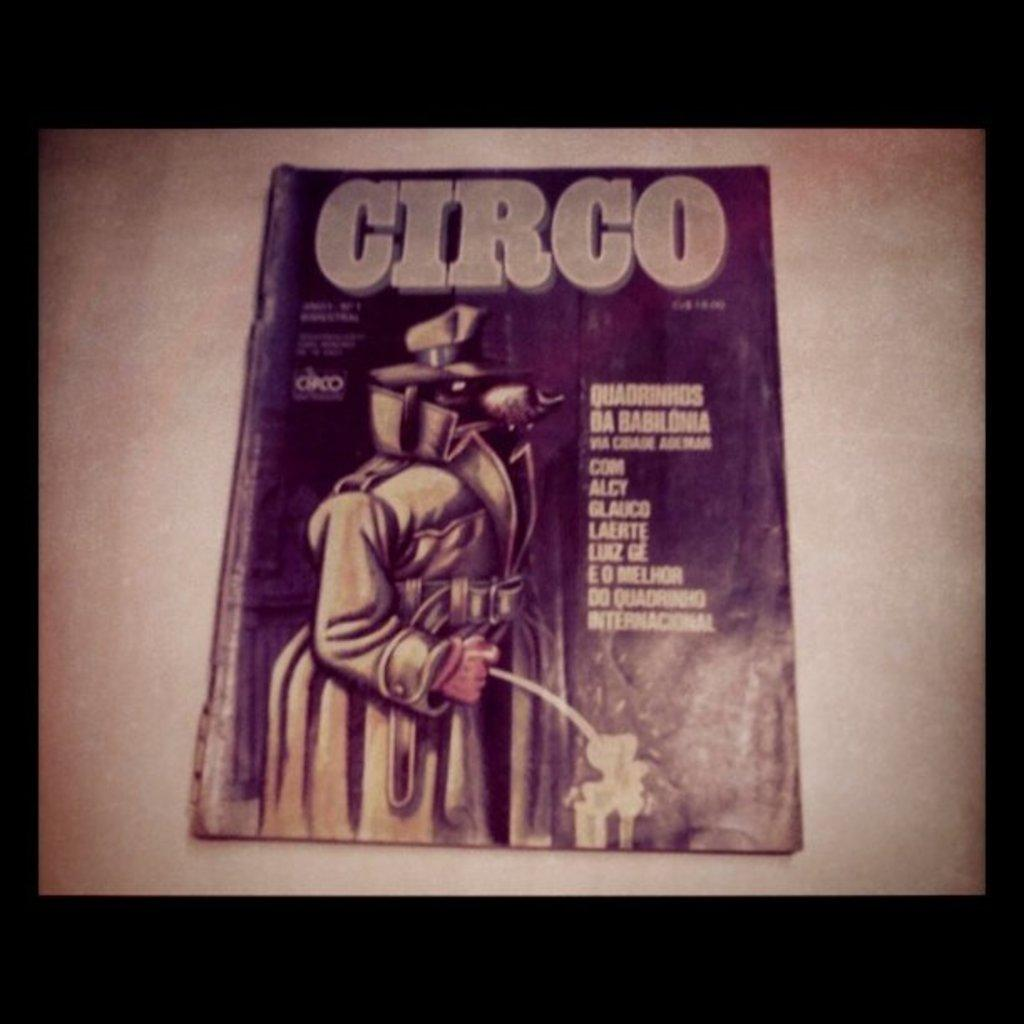<image>
Describe the image concisely. a magazine that says circo on it with a detective 